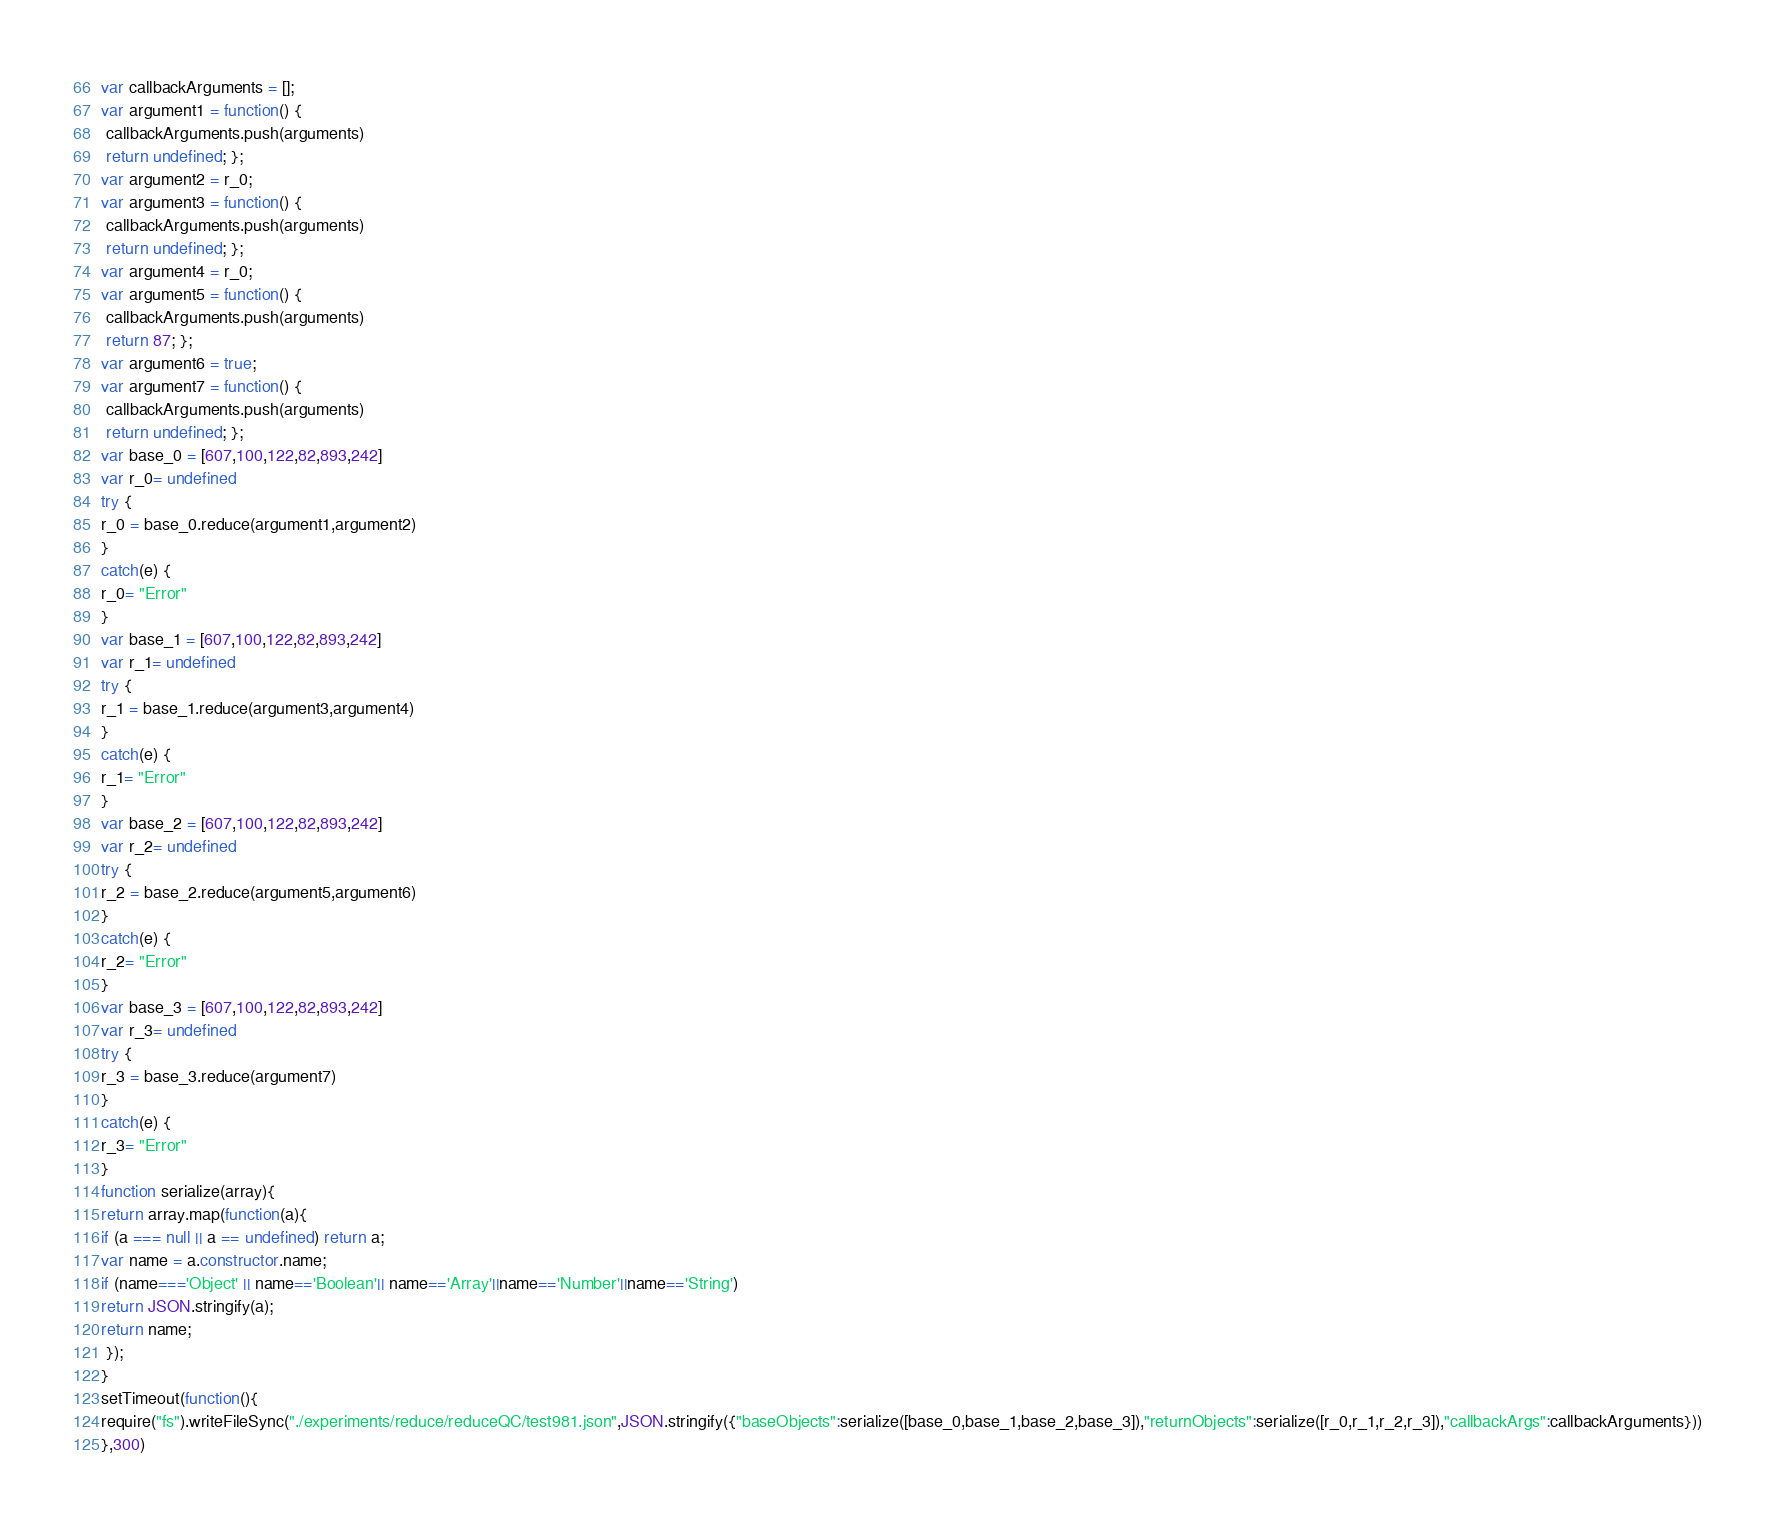Convert code to text. <code><loc_0><loc_0><loc_500><loc_500><_JavaScript_>





var callbackArguments = [];
var argument1 = function() {
 callbackArguments.push(arguments) 
 return undefined; };
var argument2 = r_0;
var argument3 = function() {
 callbackArguments.push(arguments) 
 return undefined; };
var argument4 = r_0;
var argument5 = function() {
 callbackArguments.push(arguments) 
 return 87; };
var argument6 = true;
var argument7 = function() {
 callbackArguments.push(arguments) 
 return undefined; };
var base_0 = [607,100,122,82,893,242]
var r_0= undefined
try {
r_0 = base_0.reduce(argument1,argument2)
}
catch(e) {
r_0= "Error"
}
var base_1 = [607,100,122,82,893,242]
var r_1= undefined
try {
r_1 = base_1.reduce(argument3,argument4)
}
catch(e) {
r_1= "Error"
}
var base_2 = [607,100,122,82,893,242]
var r_2= undefined
try {
r_2 = base_2.reduce(argument5,argument6)
}
catch(e) {
r_2= "Error"
}
var base_3 = [607,100,122,82,893,242]
var r_3= undefined
try {
r_3 = base_3.reduce(argument7)
}
catch(e) {
r_3= "Error"
}
function serialize(array){
return array.map(function(a){
if (a === null || a == undefined) return a;
var name = a.constructor.name;
if (name==='Object' || name=='Boolean'|| name=='Array'||name=='Number'||name=='String')
return JSON.stringify(a);
return name;
 });
}
setTimeout(function(){
require("fs").writeFileSync("./experiments/reduce/reduceQC/test981.json",JSON.stringify({"baseObjects":serialize([base_0,base_1,base_2,base_3]),"returnObjects":serialize([r_0,r_1,r_2,r_3]),"callbackArgs":callbackArguments}))
},300)</code> 